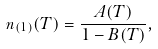<formula> <loc_0><loc_0><loc_500><loc_500>n _ { ( 1 ) } ( T ) = \frac { A ( T ) } { 1 - B ( T ) } ,</formula> 